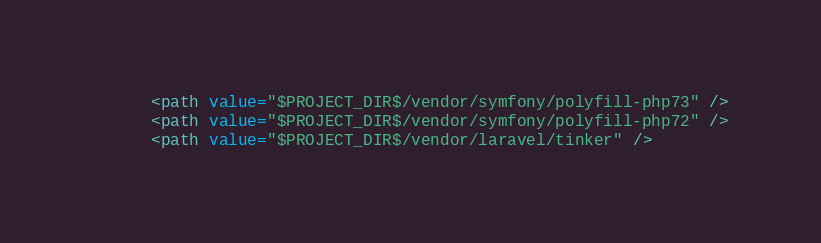<code> <loc_0><loc_0><loc_500><loc_500><_XML_>      <path value="$PROJECT_DIR$/vendor/symfony/polyfill-php73" />
      <path value="$PROJECT_DIR$/vendor/symfony/polyfill-php72" />
      <path value="$PROJECT_DIR$/vendor/laravel/tinker" /></code> 